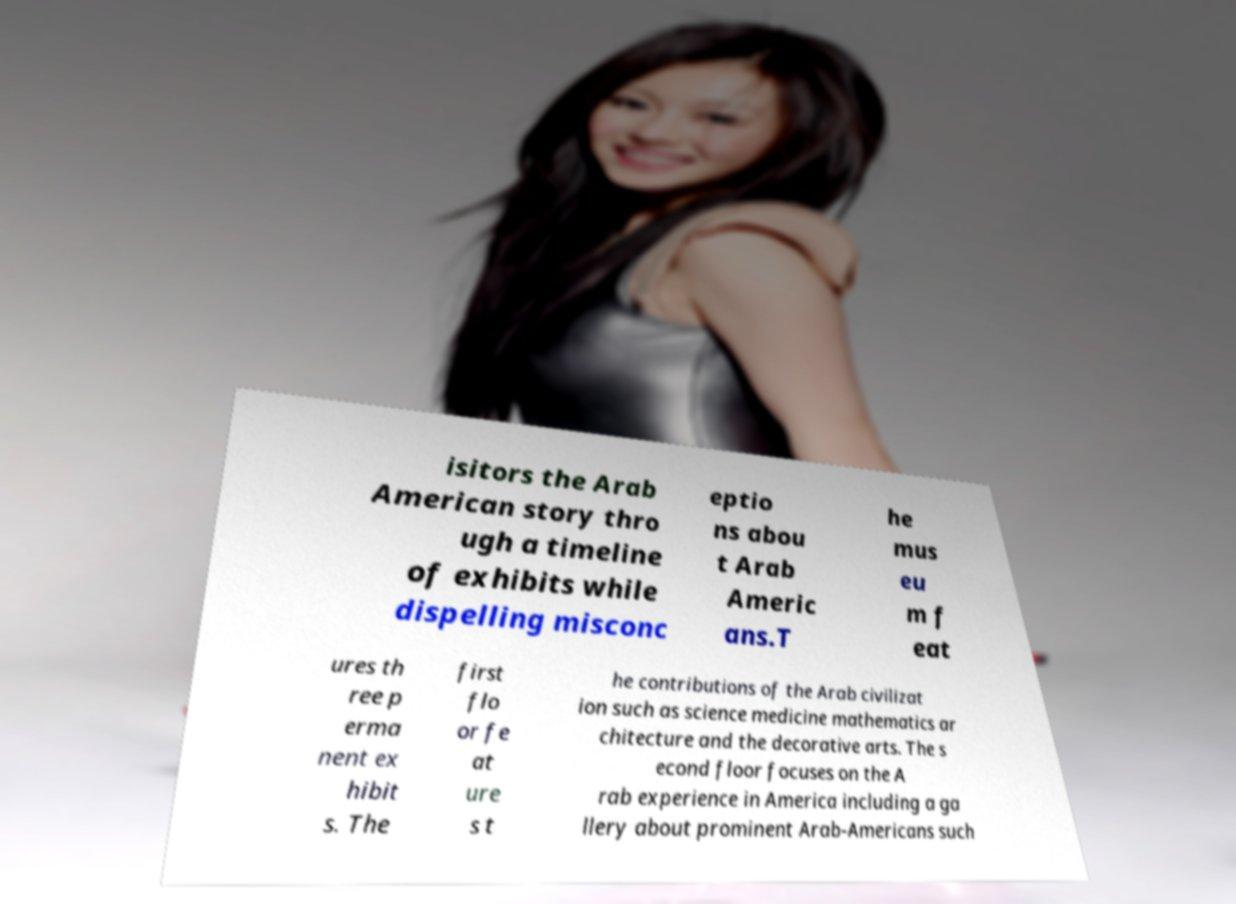For documentation purposes, I need the text within this image transcribed. Could you provide that? isitors the Arab American story thro ugh a timeline of exhibits while dispelling misconc eptio ns abou t Arab Americ ans.T he mus eu m f eat ures th ree p erma nent ex hibit s. The first flo or fe at ure s t he contributions of the Arab civilizat ion such as science medicine mathematics ar chitecture and the decorative arts. The s econd floor focuses on the A rab experience in America including a ga llery about prominent Arab-Americans such 